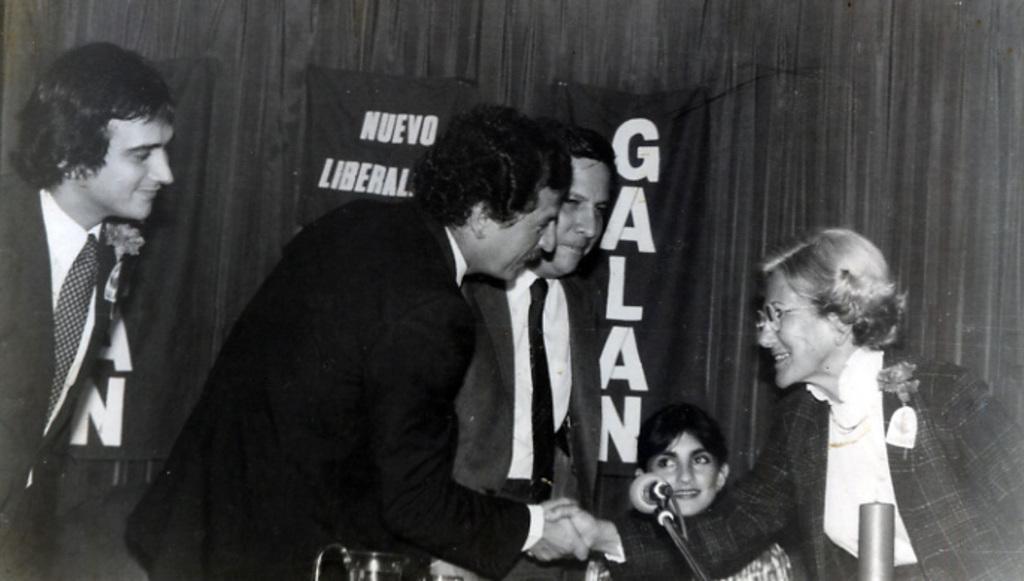Can you describe this image briefly? In the image in the center, we can see one person sitting and four persons are standing and they are smiling, which we can see on their faces. In front of them, there is a jar, microphone and a few other objects. In the background there is a wall and a banner. 